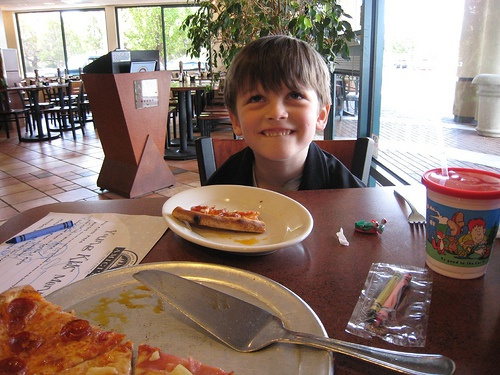Describe the objects in this image and their specific colors. I can see dining table in darkgray, maroon, black, and brown tones, people in darkgray, black, maroon, and brown tones, pizza in darkgray, brown, maroon, and gray tones, knife in darkgray, gray, maroon, and black tones, and cup in darkgray, brown, maroon, and black tones in this image. 